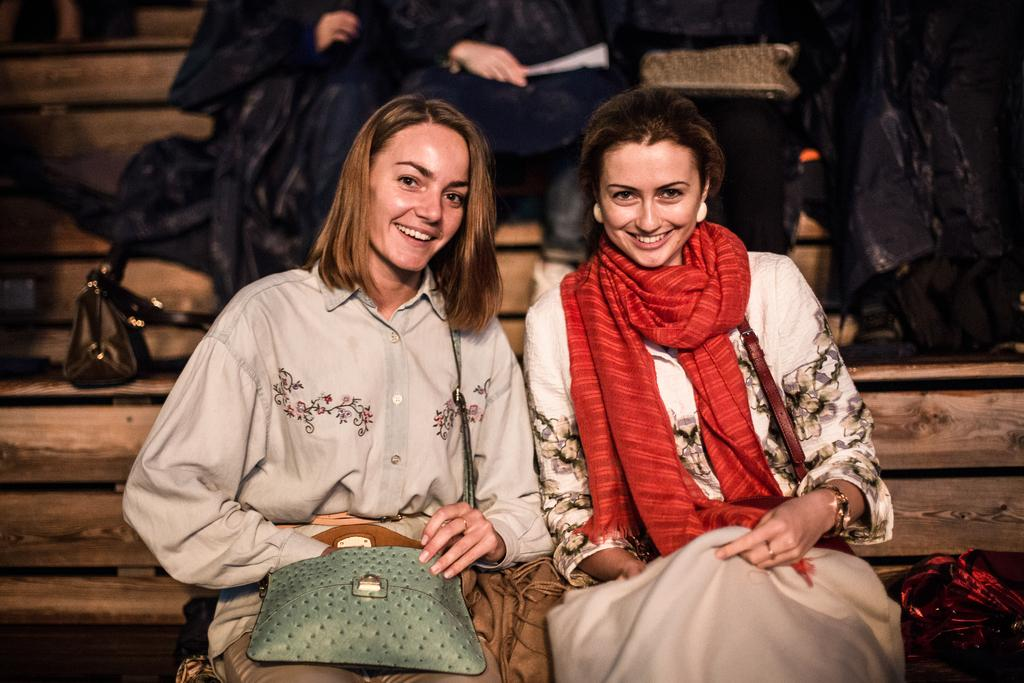How many women are in the image? There are two women in the image. What are the women doing in the image? The women are sitting on the floor and smiling. Can you describe the people in the background of the image? There are people sitting in the background of the image. What type of oven is visible in the image? There is no oven present in the image. What is the profit margin of the women in the image? There is no information about profit margins in the image, as it only shows two women sitting on the floor and smiling. 